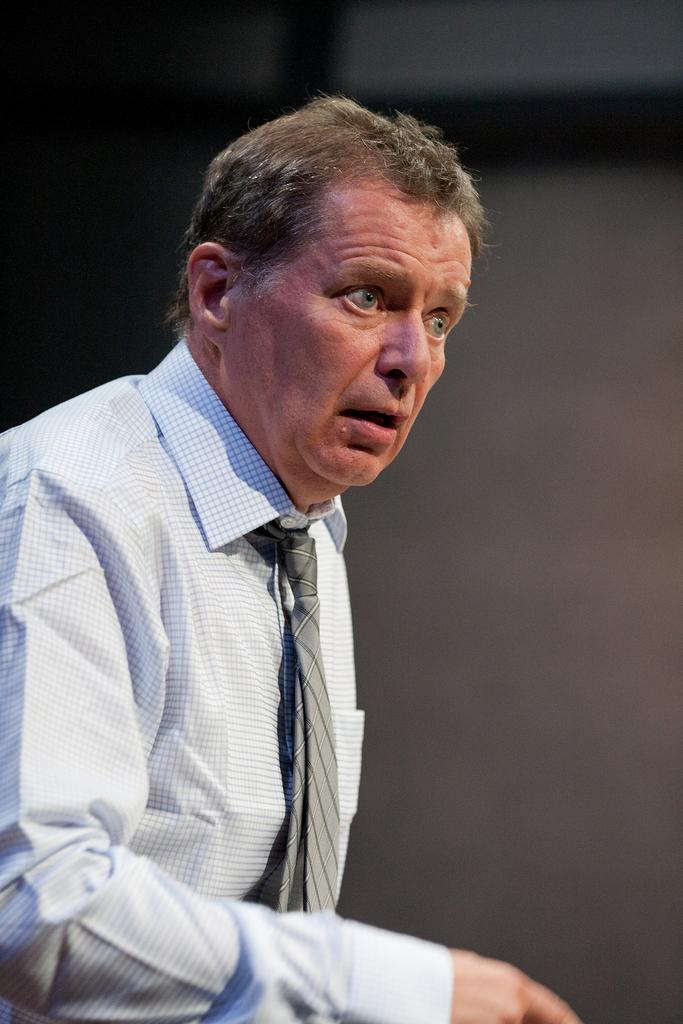What is the main subject of the image? There is a person in the image. What is the person wearing? The person is wearing a white shirt. Can you describe the background of the image? The background of the image is blurred. What type of reaction does the cat have to the calendar in the image? There is no cat or calendar present in the image. 